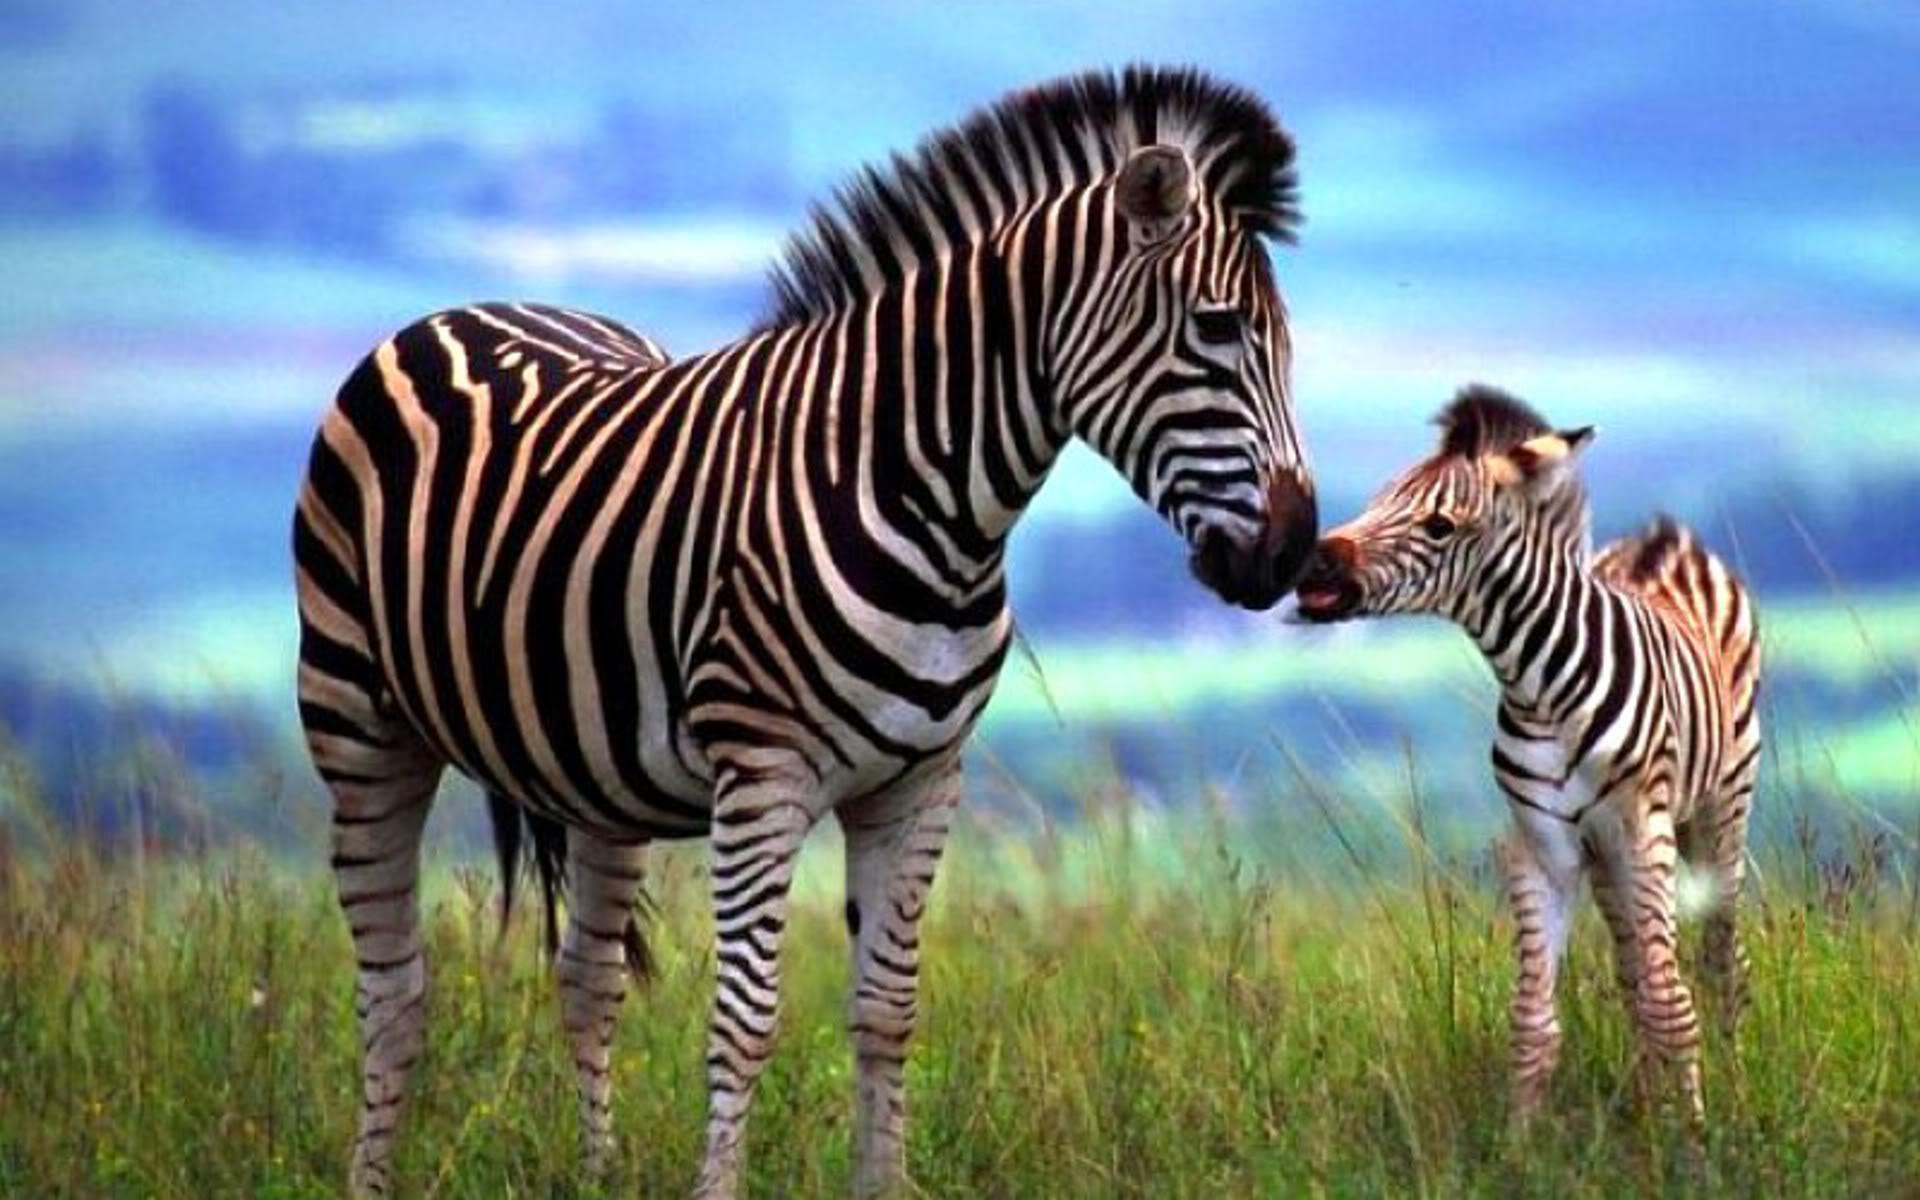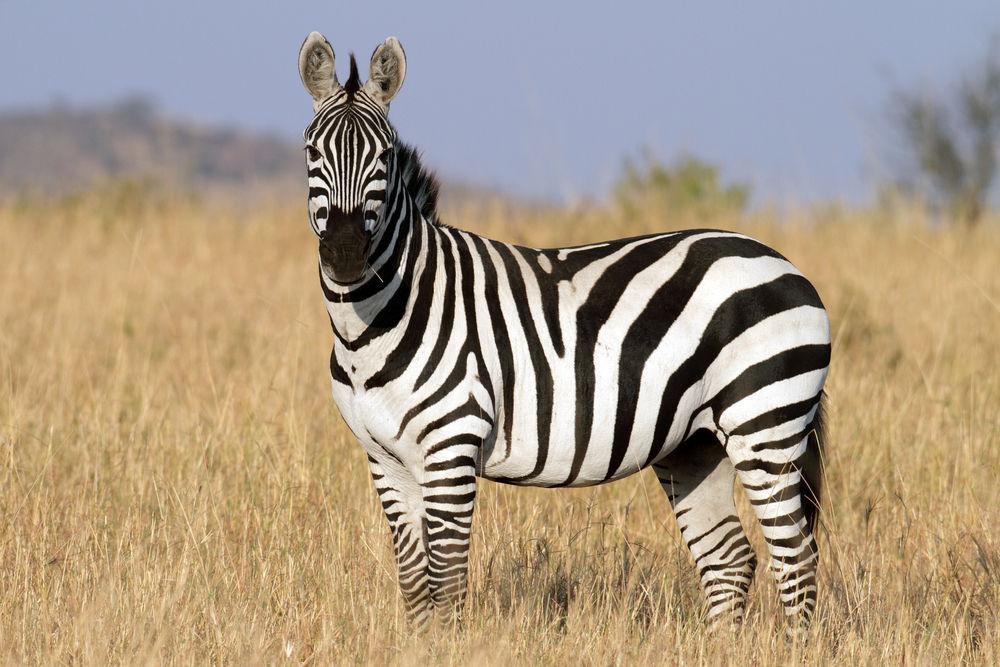The first image is the image on the left, the second image is the image on the right. Evaluate the accuracy of this statement regarding the images: "There is a mother zebra standing in the grass with her baby close to her". Is it true? Answer yes or no. Yes. The first image is the image on the left, the second image is the image on the right. Examine the images to the left and right. Is the description "The right image contains only one zebra." accurate? Answer yes or no. Yes. 